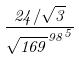Convert formula to latex. <formula><loc_0><loc_0><loc_500><loc_500>\frac { 2 4 / \sqrt { 3 } } { { \sqrt { 1 6 9 } ^ { 9 8 } } ^ { 5 } }</formula> 